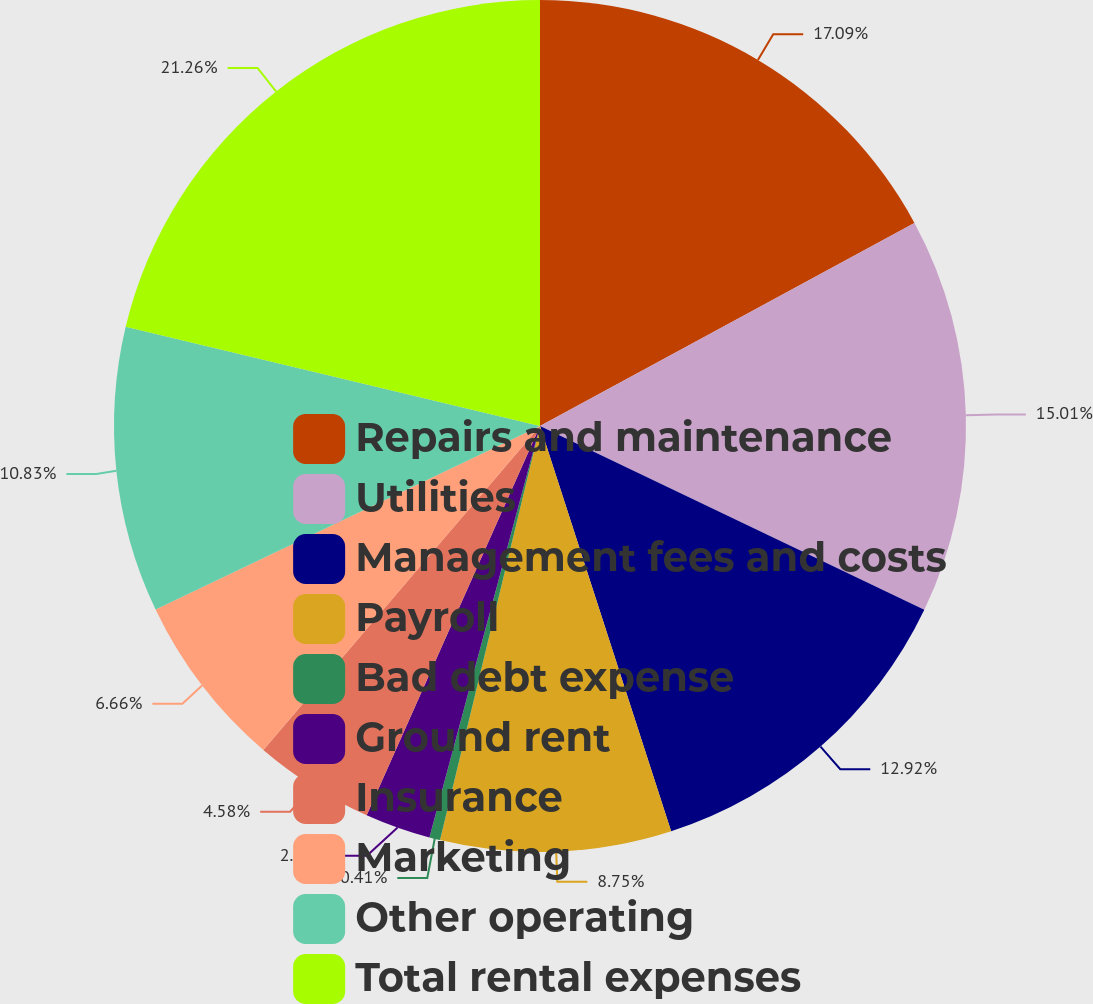Convert chart to OTSL. <chart><loc_0><loc_0><loc_500><loc_500><pie_chart><fcel>Repairs and maintenance<fcel>Utilities<fcel>Management fees and costs<fcel>Payroll<fcel>Bad debt expense<fcel>Ground rent<fcel>Insurance<fcel>Marketing<fcel>Other operating<fcel>Total rental expenses<nl><fcel>17.09%<fcel>15.01%<fcel>12.92%<fcel>8.75%<fcel>0.41%<fcel>2.49%<fcel>4.58%<fcel>6.66%<fcel>10.83%<fcel>21.26%<nl></chart> 